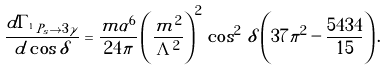Convert formula to latex. <formula><loc_0><loc_0><loc_500><loc_500>\frac { d \Gamma _ { ^ { 1 } \, P _ { s } \to 3 \gamma } } { d \cos \delta } = \frac { m \alpha ^ { 6 } } { 2 4 \pi } \left ( \frac { m ^ { 2 } } { \Lambda ^ { 2 } } \right ) ^ { 2 } \, \cos ^ { 2 } \, \delta \left ( 3 7 \pi ^ { 2 } - \frac { 5 4 3 4 } { 1 5 } \right ) .</formula> 